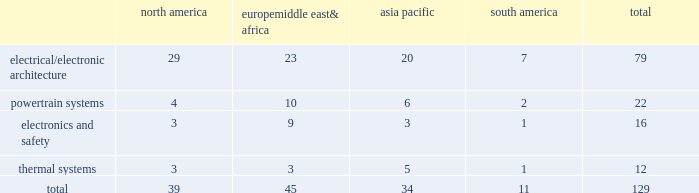Item 2 .
Properties as of december 31 , 2014 , we owned or leased 129 major manufacturing sites and 15 major technical centers in 33 countries .
A manufacturing site may include multiple plants and may be wholly or partially owned or leased .
We also have many smaller manufacturing sites , sales offices , warehouses , engineering centers , joint ventures and other investments strategically located throughout the world .
The table shows the regional distribution of our major manufacturing sites by the operating segment that uses such facilities : north america europe , middle east & africa asia pacific south america total .
In addition to these manufacturing sites , we had 15 major technical centers : five in north america ; five in europe , middle east and africa ; four in asia pacific ; and one in south america .
Of our 129 major manufacturing sites and 15 major technical centers , which include facilities owned or leased by our consolidated subsidiaries , 83 are primarily owned and 61 are primarily leased .
We frequently review our real estate portfolio and develop footprint strategies to support our customers 2019 global plans , while at the same time supporting our technical needs and controlling operating expenses .
We believe our evolving portfolio will meet current and anticipated future needs .
Item 3 .
Legal proceedings we are from time to time subject to various actions , claims , suits , government investigations , and other proceedings incidental to our business , including those arising out of alleged defects , breach of contracts , competition and antitrust matters , product warranties , intellectual property matters , personal injury claims and employment-related matters .
It is our opinion that the outcome of such matters will not have a material adverse impact on our consolidated financial position , results of operations , or cash flows .
With respect to warranty matters , although we cannot ensure that the future costs of warranty claims by customers will not be material , we believe our established reserves are adequate to cover potential warranty settlements .
However , the final amounts required to resolve these matters could differ materially from our recorded estimates .
Gm ignition switch recall in the first quarter of 2014 , gm , delphi 2019s largest customer , initiated a product recall related to ignition switches .
Delphi has received requests for information from , and is cooperating with , various government agencies related to this ignition switch recall .
In addition , delphi has been named as a co-defendant along with gm ( and in certain cases other parties ) in product liability and class action lawsuits related to this matter .
During the second quarter of 2014 , all of the class action cases were transferred to the united states district court for the southern district of new york ( the 201cdistrict court 201d ) for coordinated pretrial proceedings .
Two consolidated amended class action complaints were filed in the district court on october 14 , 2014 .
Delphi was not named as a defendant in either complaint .
Delphi believes the allegations contained in the product liability cases are without merit , and intends to vigorously defend against them .
Although no assurances can be made as to the ultimate outcome of these or any other future claims , delphi does not believe a loss is probable and , accordingly , no reserve has been made as of december 31 , 2014 .
Unsecured creditors litigation under the terms of the fourth amended and restated limited liability partnership agreement of delphi automotive llp ( the 201cfourth llp agreement 201d ) , if cumulative distributions to the members of delphi automotive llp under certain provisions of the fourth llp agreement exceed $ 7.2 billion , delphi , as disbursing agent on behalf of dphh , is required to pay to the holders of allowed general unsecured claims against old delphi , $ 32.50 for every $ 67.50 in excess of $ 7.2 billion distributed to the members , up to a maximum amount of $ 300 million .
In december 2014 , a complaint was filed in the bankruptcy court alleging that the redemption by delphi automotive llp of the membership interests of gm and the pbgc , and the repurchase of shares and payment of dividends by delphi automotive plc , constituted distributions under the terms of the fourth llp agreement approximating $ 7.2 billion .
Delphi considers cumulative distributions through december 31 , 2014 to be substantially below the $ 7.2 billion threshold , and intends to vigorously contest the allegations set forth in the complaint .
Accordingly , no accrual for this matter has been recorded as of december 31 , 2014. .
What is the percentage of south america's sites among all sites? 
Rationale: it is the number of south america's sites divided by all sites , then turned into a percentage .
Computations: (11 / 129)
Answer: 0.08527. 